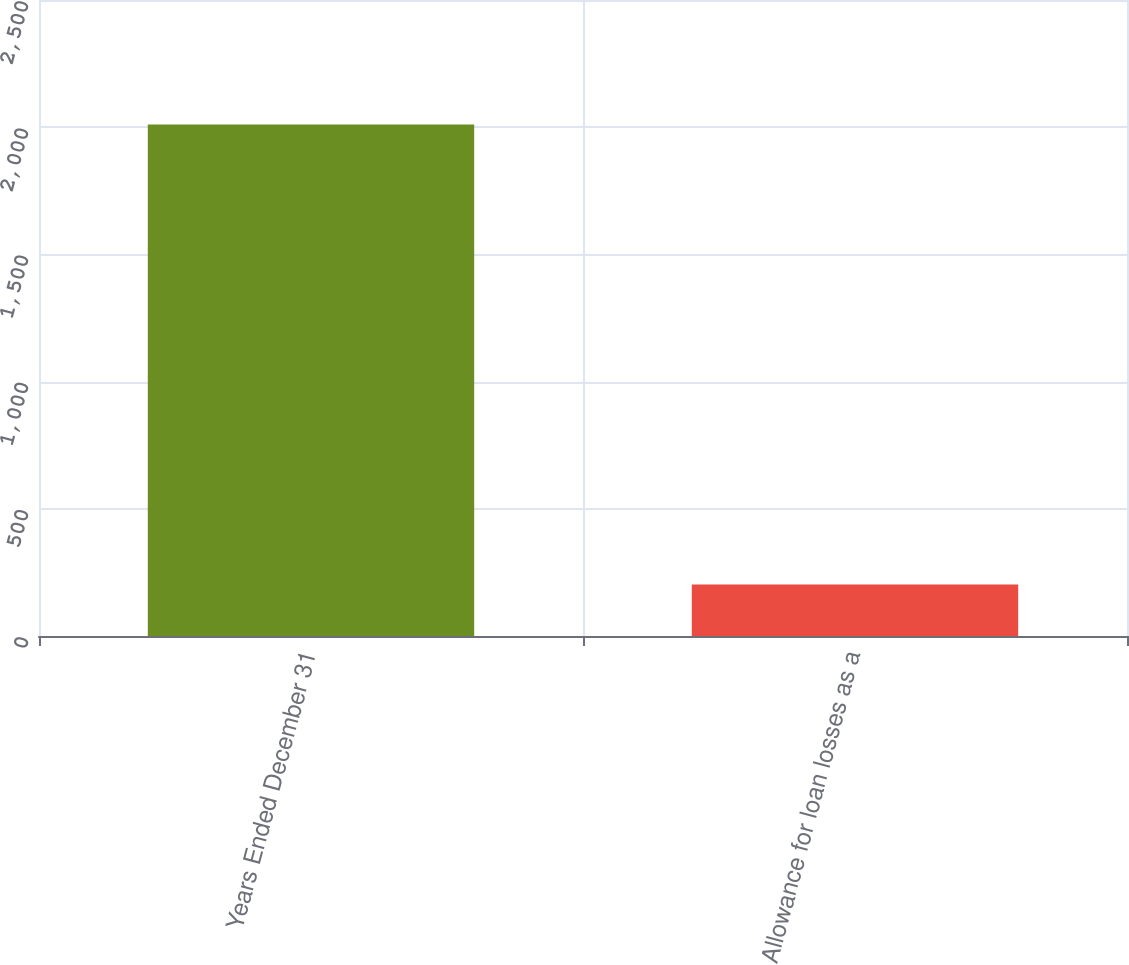Convert chart. <chart><loc_0><loc_0><loc_500><loc_500><bar_chart><fcel>Years Ended December 31<fcel>Allowance for loan losses as a<nl><fcel>2011<fcel>202.63<nl></chart> 